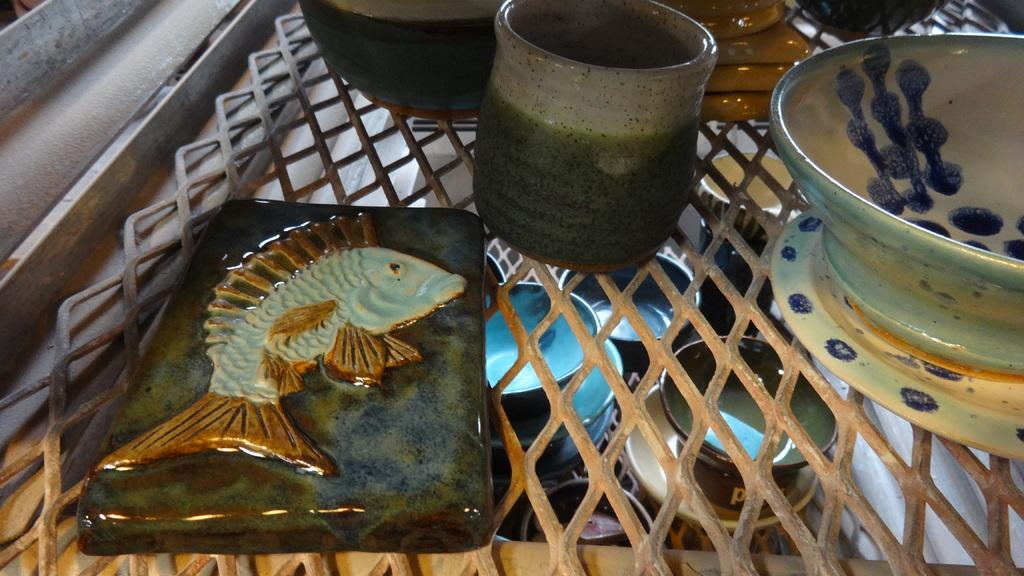What type of furniture is present in the image? There is a table in the image. What objects are placed on the table? There are ceramic bowls and cups on the table. What other feature can be seen in the image? There is a bar in the image. What symbol is associated with the bar? The bar has a fish symbol. Where are the cups located in relation to the image? There are cups arranged at the bottom of the image. How does the loaf of bread express anger in the image? There is no loaf of bread present in the image, so it cannot express any emotions. 